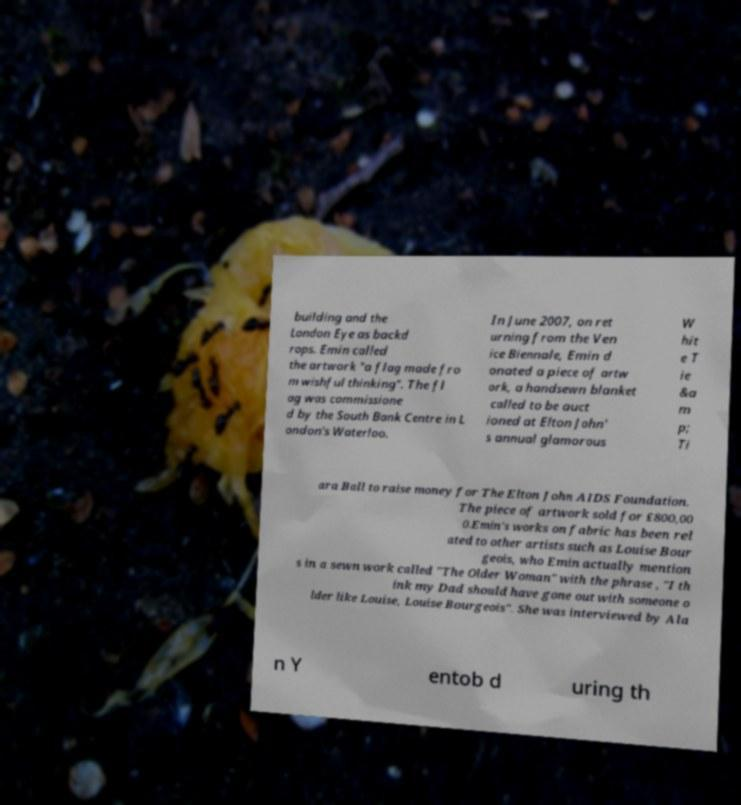Can you read and provide the text displayed in the image?This photo seems to have some interesting text. Can you extract and type it out for me? building and the London Eye as backd rops. Emin called the artwork "a flag made fro m wishful thinking". The fl ag was commissione d by the South Bank Centre in L ondon's Waterloo. In June 2007, on ret urning from the Ven ice Biennale, Emin d onated a piece of artw ork, a handsewn blanket called to be auct ioned at Elton John' s annual glamorous W hit e T ie &a m p; Ti ara Ball to raise money for The Elton John AIDS Foundation. The piece of artwork sold for £800,00 0.Emin's works on fabric has been rel ated to other artists such as Louise Bour geois, who Emin actually mention s in a sewn work called "The Older Woman" with the phrase , "I th ink my Dad should have gone out with someone o lder like Louise, Louise Bourgeois". She was interviewed by Ala n Y entob d uring th 